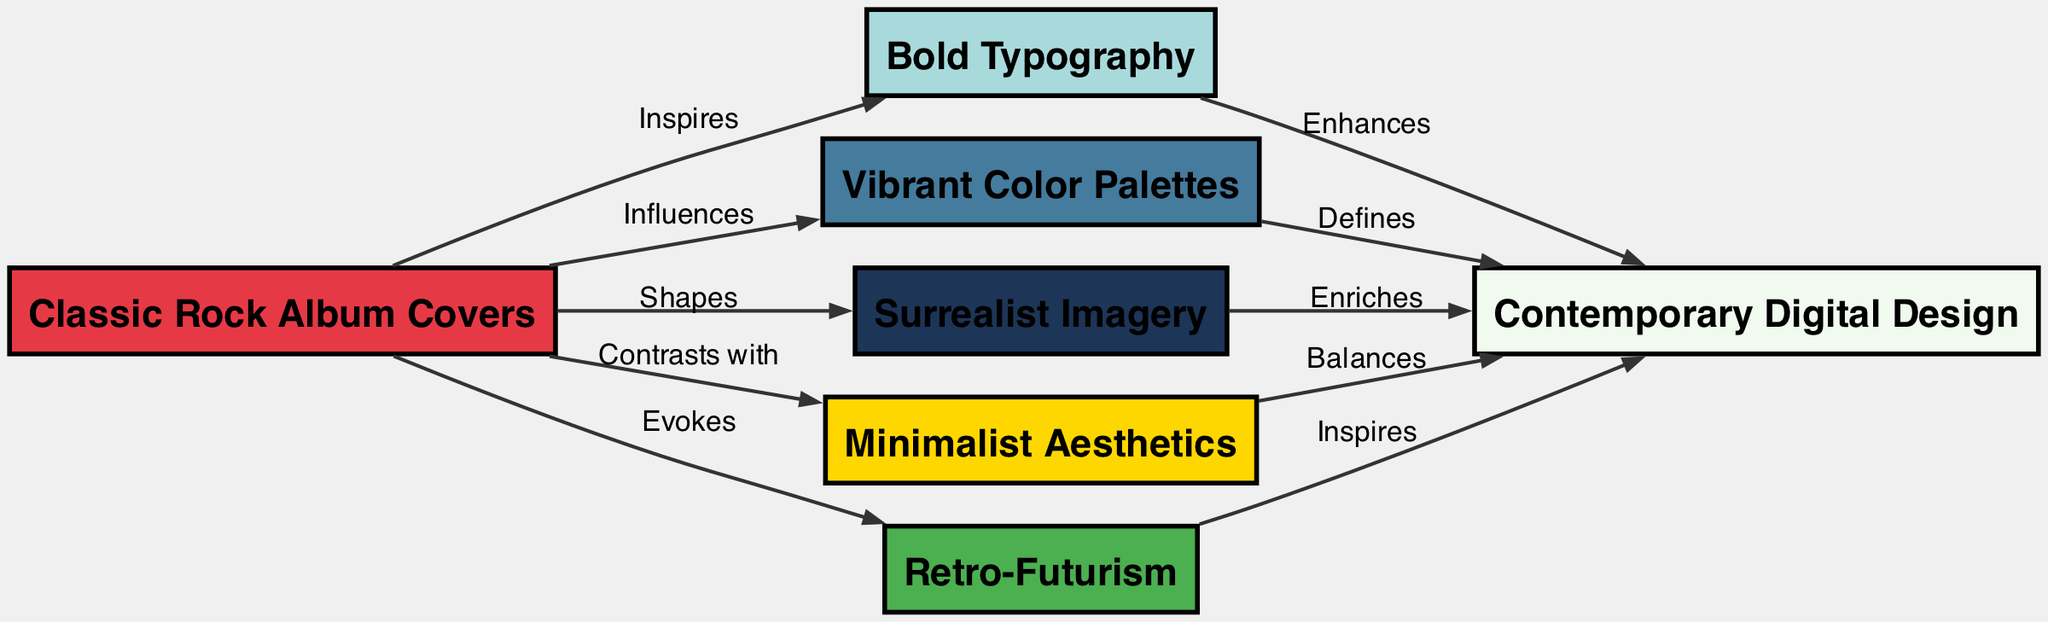What is the total number of nodes in the diagram? The diagram lists 6 distinct nodes: Classic Rock Album Covers, Contemporary Digital Design, Bold Typography, Vibrant Color Palettes, Surrealist Imagery, Minimalist Aesthetics, and Retro-Futurism. Thus, by counting the individual nodes, we confirm that there are 6 nodes in total.
Answer: 6 Which node influences Color? According to the edges outlined in the diagram, Classic Rock Album Covers has a directed edge pointing to Color with the label "Influences", indicating that it is the node that affects Color.
Answer: Classic Rock Album Covers What is the relationship between Typography and Digital Design? The diagram shows a directed edge from Typography to Digital Design, labeled "Enhances". This indicates that Typography contributes positively to Digital Design, enhancing its value.
Answer: Enhances How many edges are connected to Classic Rock Album Covers? Upon examining the diagram, Classic Rock Album Covers is connected to five separate nodes through directed edges: Typography, Color, Imagery, Minimalism, and Nostalgia. Therefore, we can conclude that there are 5 edges connected to this node.
Answer: 5 What does Nostalgia inspire in the context of this diagram? The relationship between Nostalgia and Digital Design is shown by a directed edge labeled "Inspires". This indicates that Nostalgia has a significant positive impact on Digital Design, serving as a source of inspiration.
Answer: Digital Design What aspect does Minimalism balance in Digital Design? The diagram illustrates that Minimalism balances aspects of Digital Design through a directed edge labeled "Balances". This suggests that Minimalism contributes to creating a sense of equilibrium or harmony within the broader scope of Digital Design.
Answer: Digital Design Which node evokes Nostalgia? The diagram shows a directed edge from Classic Rock Album Covers to Nostalgia labeled "Evokes", establishing that Classic Rock Album Covers plays a crucial role in conjuring feelings of Nostalgia.
Answer: Classic Rock Album Covers What is the primary influence of Color on Digital Design? The relationship depicted in the diagram shows Color has a defined impact on Digital Design, indicated by the edge labeled "Defines". This means Color shapes or primarily determines the characteristics of Digital Design.
Answer: Defines 